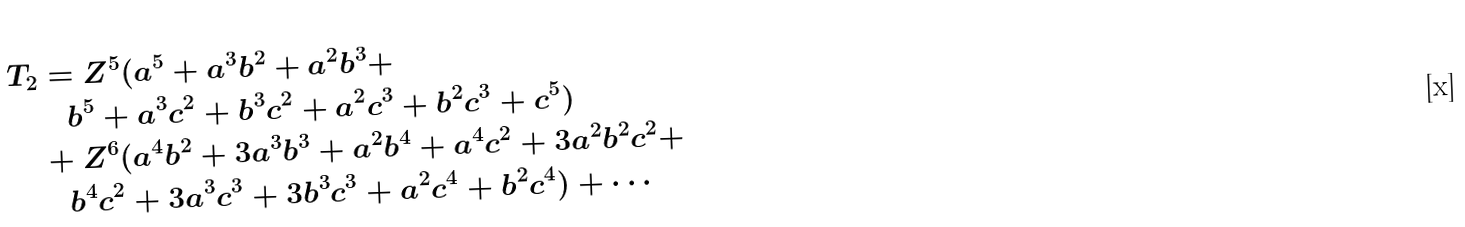<formula> <loc_0><loc_0><loc_500><loc_500>T _ { 2 } & = Z ^ { 5 } ( a ^ { 5 } + a ^ { 3 } b ^ { 2 } + a ^ { 2 } b ^ { 3 } + \\ & \quad b ^ { 5 } + a ^ { 3 } c ^ { 2 } + b ^ { 3 } c ^ { 2 } + a ^ { 2 } c ^ { 3 } + b ^ { 2 } c ^ { 3 } + c ^ { 5 } ) \\ & + Z ^ { 6 } ( a ^ { 4 } b ^ { 2 } + 3 a ^ { 3 } b ^ { 3 } + a ^ { 2 } b ^ { 4 } + a ^ { 4 } c ^ { 2 } + 3 a ^ { 2 } b ^ { 2 } c ^ { 2 } + \\ & \quad b ^ { 4 } c ^ { 2 } + 3 a ^ { 3 } c ^ { 3 } + 3 b ^ { 3 } c ^ { 3 } + a ^ { 2 } c ^ { 4 } + b ^ { 2 } c ^ { 4 } ) + \cdots</formula> 